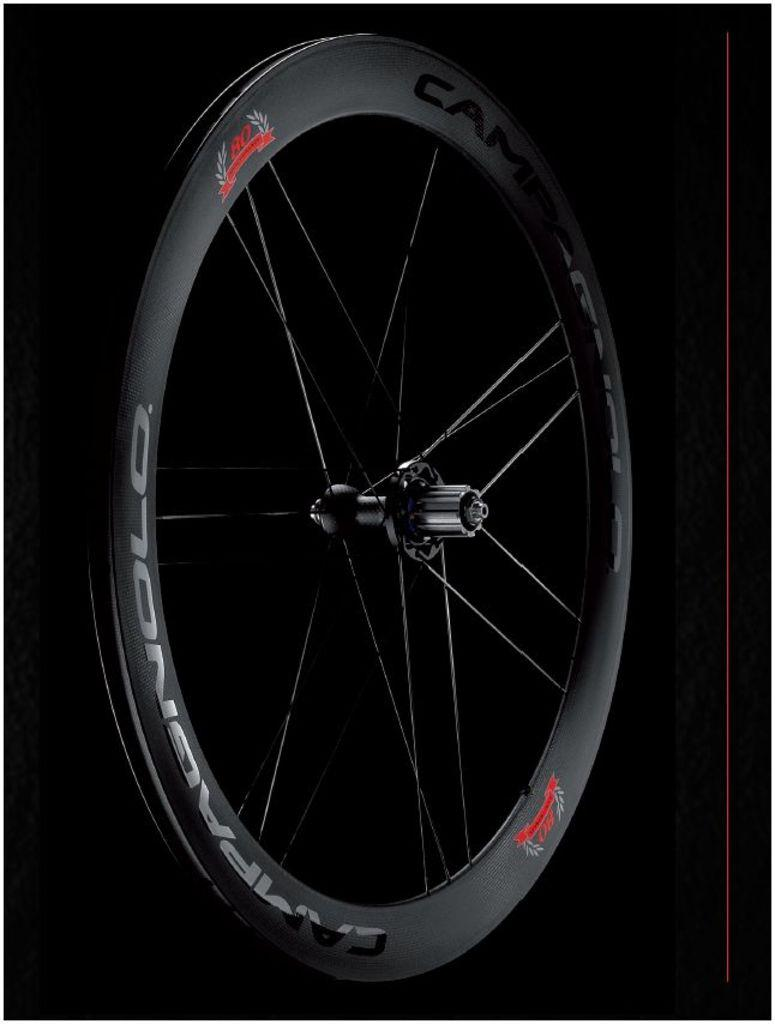What is the main object in the image? There is a wheel in the image. What are the spokes on the wheel? The wheel has spokes. What can be observed about the background of the image? The background of the image is dark. What is written or depicted on the wheel? There is text on the wheel. Can you tell me how many dolls are sitting on the wheel in the image? There are no dolls present in the image; it features a wheel with spokes and text. What type of footwear is the writer wearing in the image? There is no writer or footwear present in the image; it only features a wheel with spokes and text. 